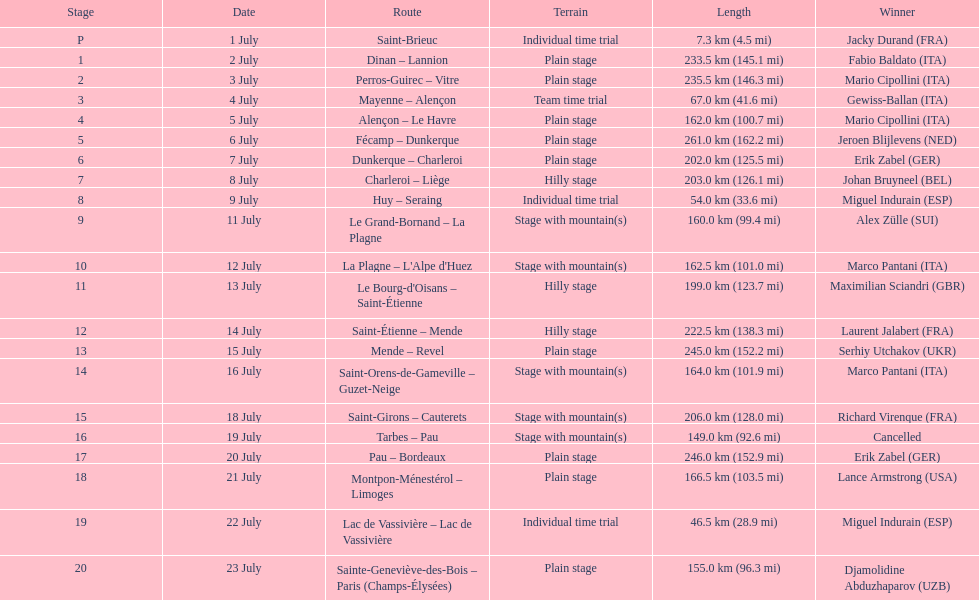Which country had more stage-winners than any other country? Italy. 